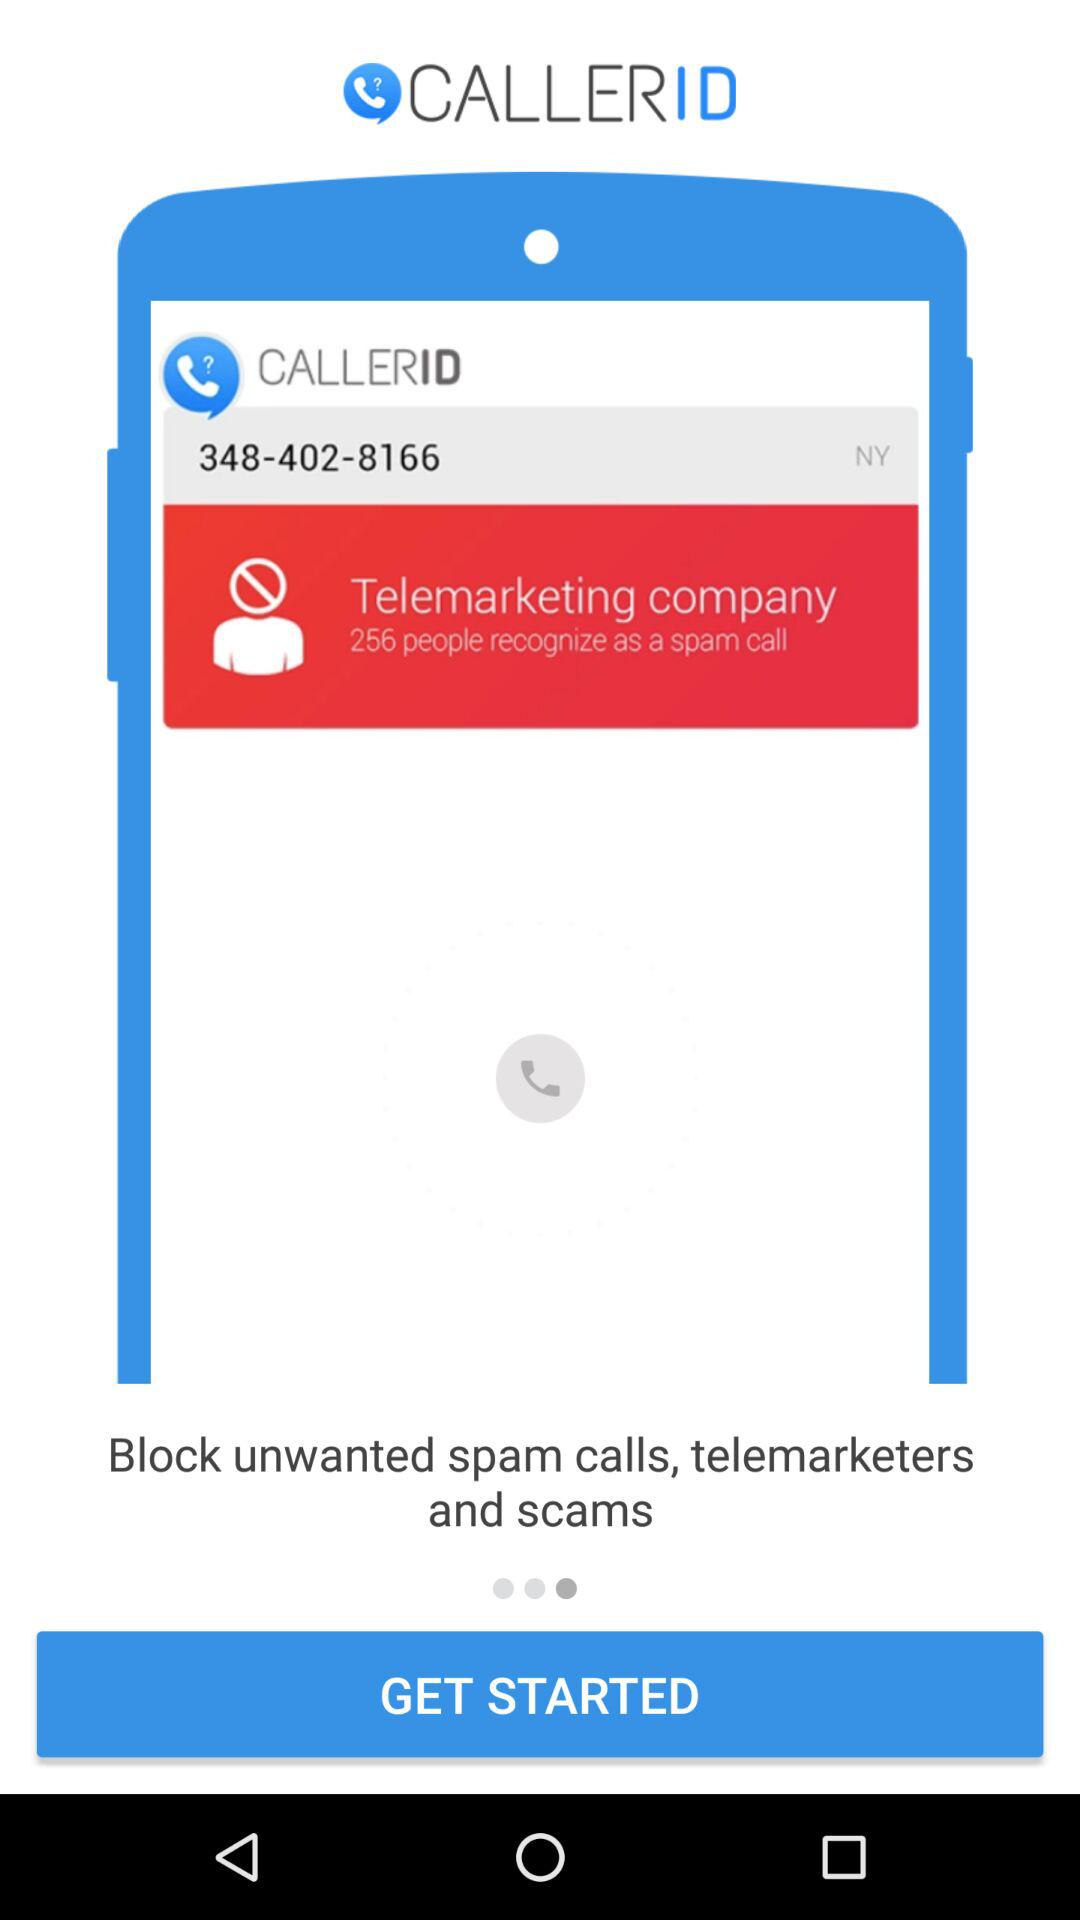What is the application name? The application name is "CALLERID". 